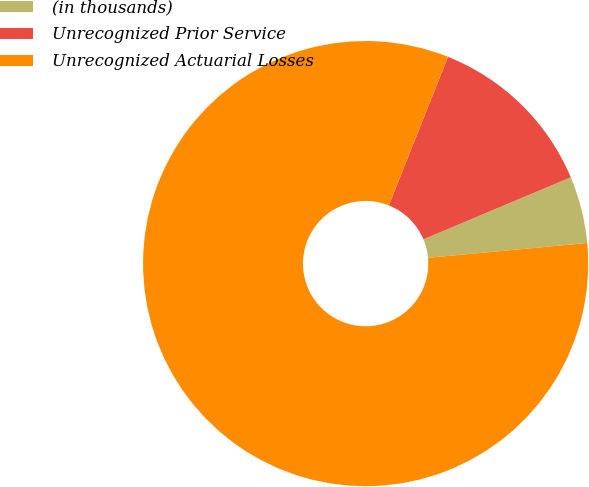Convert chart. <chart><loc_0><loc_0><loc_500><loc_500><pie_chart><fcel>(in thousands)<fcel>Unrecognized Prior Service<fcel>Unrecognized Actuarial Losses<nl><fcel>4.86%<fcel>12.63%<fcel>82.51%<nl></chart> 